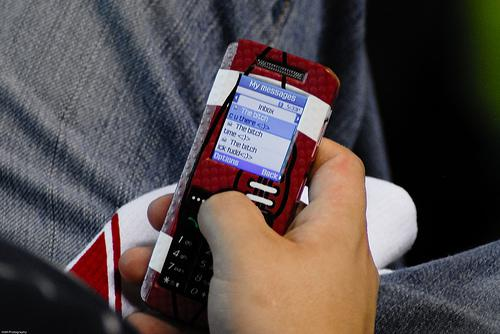Question: who is holding the phone?
Choices:
A. The man.
B. The woman.
C. The boy.
D. The girl.
Answer with the letter. Answer: A Question: how many people are there?
Choices:
A. 12.
B. 13.
C. 5.
D. 1.
Answer with the letter. Answer: D Question: what is the man holding?
Choices:
A. Golf club.
B. Bat.
C. The phone.
D. Hat.
Answer with the letter. Answer: C Question: where was the photo taken?
Choices:
A. On someone's lap.
B. In a rose garden.
C. At a casino.
D. In a grocery store.
Answer with the letter. Answer: A 